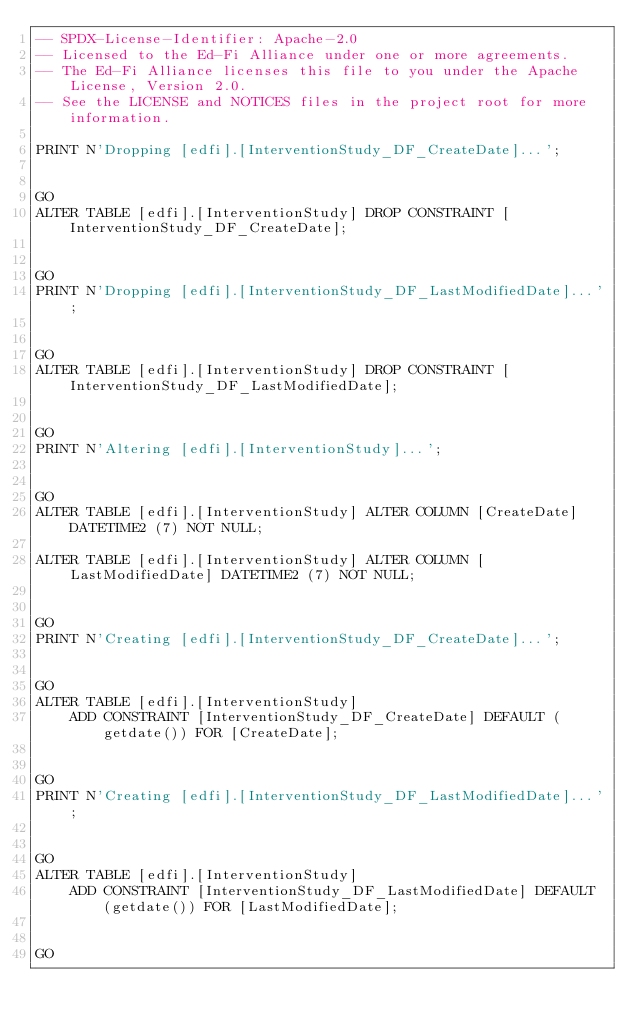<code> <loc_0><loc_0><loc_500><loc_500><_SQL_>-- SPDX-License-Identifier: Apache-2.0
-- Licensed to the Ed-Fi Alliance under one or more agreements.
-- The Ed-Fi Alliance licenses this file to you under the Apache License, Version 2.0.
-- See the LICENSE and NOTICES files in the project root for more information.

PRINT N'Dropping [edfi].[InterventionStudy_DF_CreateDate]...';


GO
ALTER TABLE [edfi].[InterventionStudy] DROP CONSTRAINT [InterventionStudy_DF_CreateDate];


GO
PRINT N'Dropping [edfi].[InterventionStudy_DF_LastModifiedDate]...';


GO
ALTER TABLE [edfi].[InterventionStudy] DROP CONSTRAINT [InterventionStudy_DF_LastModifiedDate];


GO
PRINT N'Altering [edfi].[InterventionStudy]...';


GO
ALTER TABLE [edfi].[InterventionStudy] ALTER COLUMN [CreateDate] DATETIME2 (7) NOT NULL;

ALTER TABLE [edfi].[InterventionStudy] ALTER COLUMN [LastModifiedDate] DATETIME2 (7) NOT NULL;


GO
PRINT N'Creating [edfi].[InterventionStudy_DF_CreateDate]...';


GO
ALTER TABLE [edfi].[InterventionStudy]
    ADD CONSTRAINT [InterventionStudy_DF_CreateDate] DEFAULT (getdate()) FOR [CreateDate];


GO
PRINT N'Creating [edfi].[InterventionStudy_DF_LastModifiedDate]...';


GO
ALTER TABLE [edfi].[InterventionStudy]
    ADD CONSTRAINT [InterventionStudy_DF_LastModifiedDate] DEFAULT (getdate()) FOR [LastModifiedDate];


GO
</code> 